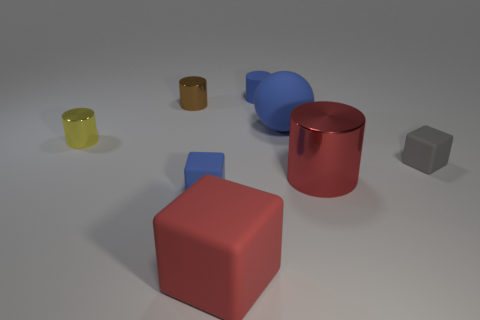Are there any other things that have the same shape as the big blue matte object?
Offer a very short reply. No. Is the number of rubber cylinders less than the number of big things?
Make the answer very short. Yes. Is the color of the large metal object the same as the big cube?
Provide a short and direct response. Yes. Is the number of tiny shiny cylinders greater than the number of cubes?
Offer a terse response. No. What number of other things are the same color as the large metallic thing?
Your answer should be very brief. 1. What number of blue things are on the left side of the small blue matte thing that is right of the large block?
Your answer should be very brief. 1. Are there any small blue rubber things on the left side of the small gray matte cube?
Ensure brevity in your answer.  Yes. The small blue object that is in front of the metallic object that is to the left of the tiny brown metallic cylinder is what shape?
Offer a terse response. Cube. Is the number of big blue rubber things that are in front of the yellow metallic thing less than the number of small blocks in front of the large red metallic thing?
Offer a terse response. Yes. There is another big metal object that is the same shape as the yellow thing; what is its color?
Your answer should be compact. Red. 